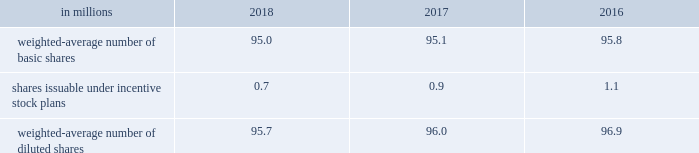Note 18 2013 earnings per share ( eps ) basic eps is calculated by dividing net earnings attributable to allegion plc by the weighted-average number of ordinary shares outstanding for the applicable period .
Diluted eps is calculated after adjusting the denominator of the basic eps calculation for the effect of all potentially dilutive ordinary shares , which in the company 2019s case , includes shares issuable under share-based compensation plans .
The table summarizes the weighted-average number of ordinary shares outstanding for basic and diluted earnings per share calculations: .
At december 31 , 2018 , 0.1 million stock options were excluded from the computation of weighted-average diluted shares outstanding because the effect of including these shares would have been anti-dilutive .
Note 19 2013 net revenues net revenues are recognized based on the satisfaction of performance obligations under the terms of a contract .
A performance obligation is a promise in a contract to transfer control of a distinct product or to provide a service , or a bundle of products or services , to a customer , and is the unit of account under asc 606 .
The company has two principal revenue streams , tangible product sales and services .
Approximately 99% ( 99 % ) of consolidated net revenues involve contracts with a single performance obligation , which is the transfer of control of a product or bundle of products to a customer .
Transfer of control typically occurs when goods are shipped from the company's facilities or at other predetermined control transfer points ( for instance , destination terms ) .
Net revenues are measured as the amount of consideration expected to be received in exchange for transferring control of the products and takes into account variable consideration , such as sales incentive programs including discounts and volume rebates .
The existence of these programs does not preclude revenue recognition but does require the company's best estimate of the variable consideration to be made based on expected activity , as these items are reserved for as a deduction to net revenues over time based on the company's historical rates of providing these incentives and annual forecasted sales volumes .
The company also offers a standard warranty with most product sales and the value of such warranty is included in the contractual price .
The corresponding cost of the warranty obligation is accrued as a liability ( see note 20 ) .
The company's remaining net revenues involve services , including installation and consulting .
Unlike the single performance obligation to ship a product or bundle of products , the service revenue stream delays revenue recognition until the service performance obligations are satisfied .
In some instances , customer acceptance provisions are included in sales arrangements to give the buyer the ability to ensure the service meets the criteria established in the order .
In these instances , revenue recognition is deferred until the performance obligations are satisfied , which could include acceptance terms specified in the arrangement being fulfilled through customer acceptance or a demonstration that established criteria have been satisfied .
During the year ended december 31 , 2018 , no adjustments related to performance obligations satisfied in previous periods were recorded .
Upon adoption of asc 606 , the company used the practical expedients to omit the disclosure of remaining performance obligations for contracts with an original expected duration of one year or less and for contracts where the company has the right to invoice for performance completed to date .
The transaction price is not adjusted for the effects of a significant financing component , as the time period between control transfer of goods and services is less than one year .
Sales , value-added and other similar taxes collected by the company are excluded from net revenues .
The company has also elected to account for shipping and handling activities that occur after control of the related goods transfers as fulfillment activities instead of performance obligations .
These activities are included in cost of goods sold in the consolidated statements of comprehensive income .
The company 2019s payment terms are generally consistent with the industries in which their businesses operate .
The following table shows the company's net revenues for the years ended december 31 , based on the two principal revenue streams , tangible product sales and services , disaggregated by business segment .
Net revenues are shown by tangible product sales and services , as contract terms , conditions and economic factors affecting the nature , amount , timing and uncertainty around revenue recognition and cash flows are substantially similar within each of the two principal revenue streams: .
Considering the years 2016-2018 , what is the average value of diluted earnings per share issuable under incentive stock plans? 
Rationale: it is the sum of all diluted earnings per shares issuable under incentive stock plans in these three years , then divided by three .
Computations: table_average(shares issuable under incentive stock plans, none)
Answer: 0.9. 